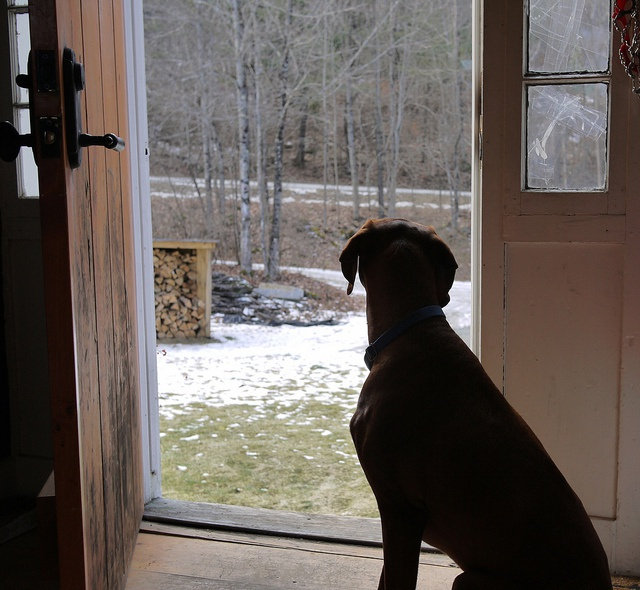Describe the objects in this image and their specific colors. I can see a dog in black, gray, lightgray, and darkgray tones in this image. 